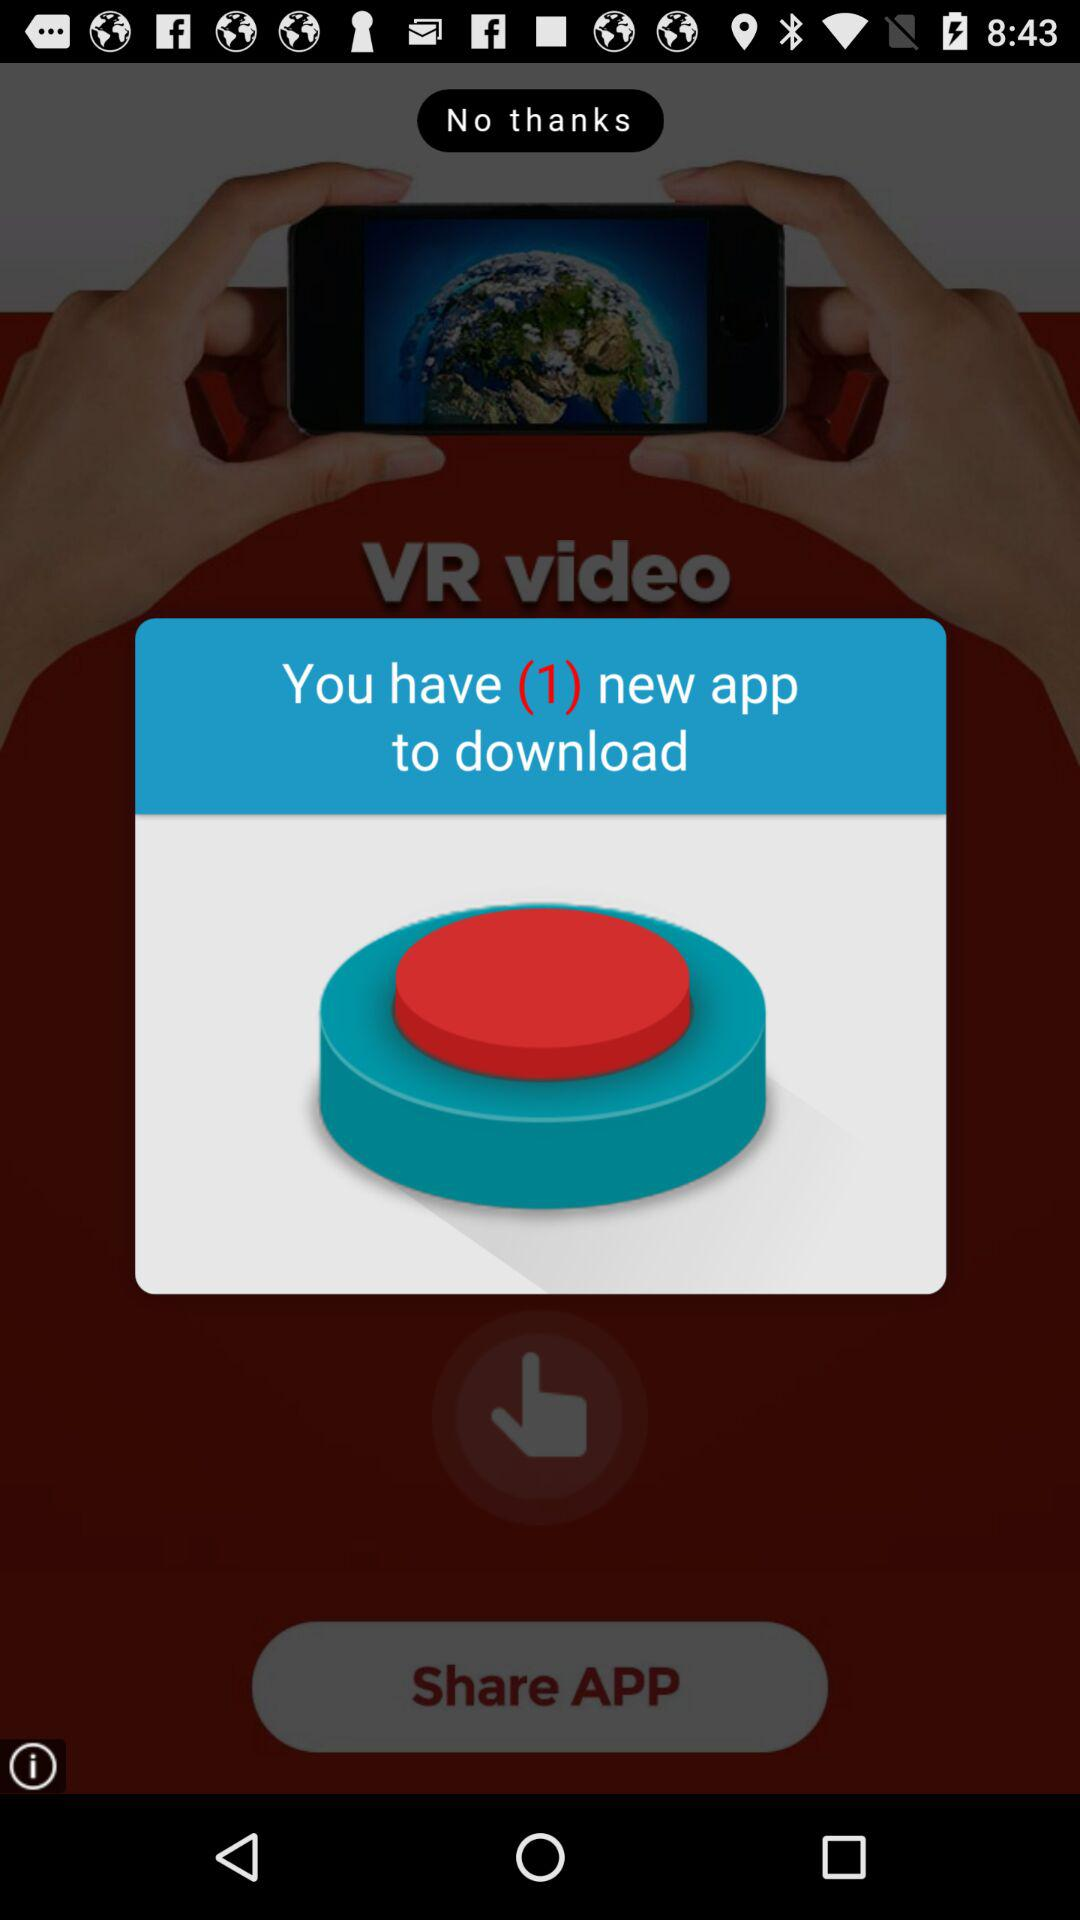How many new applications are there to download? There is 1 new application to download. 